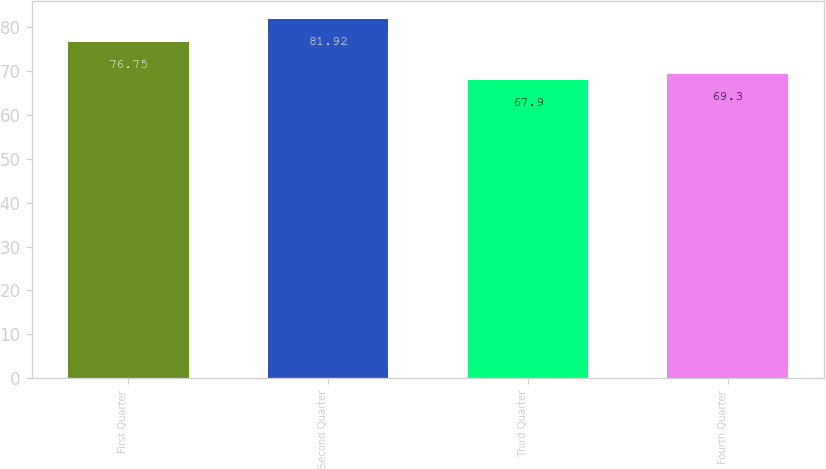Convert chart. <chart><loc_0><loc_0><loc_500><loc_500><bar_chart><fcel>First Quarter<fcel>Second Quarter<fcel>Third Quarter<fcel>Fourth Quarter<nl><fcel>76.75<fcel>81.92<fcel>67.9<fcel>69.3<nl></chart> 